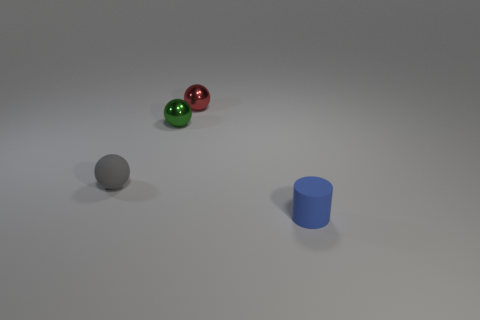Add 3 matte spheres. How many objects exist? 7 Subtract all cylinders. How many objects are left? 3 Subtract 0 blue balls. How many objects are left? 4 Subtract all small cyan metal spheres. Subtract all tiny green metal things. How many objects are left? 3 Add 2 gray rubber balls. How many gray rubber balls are left? 3 Add 1 small green things. How many small green things exist? 2 